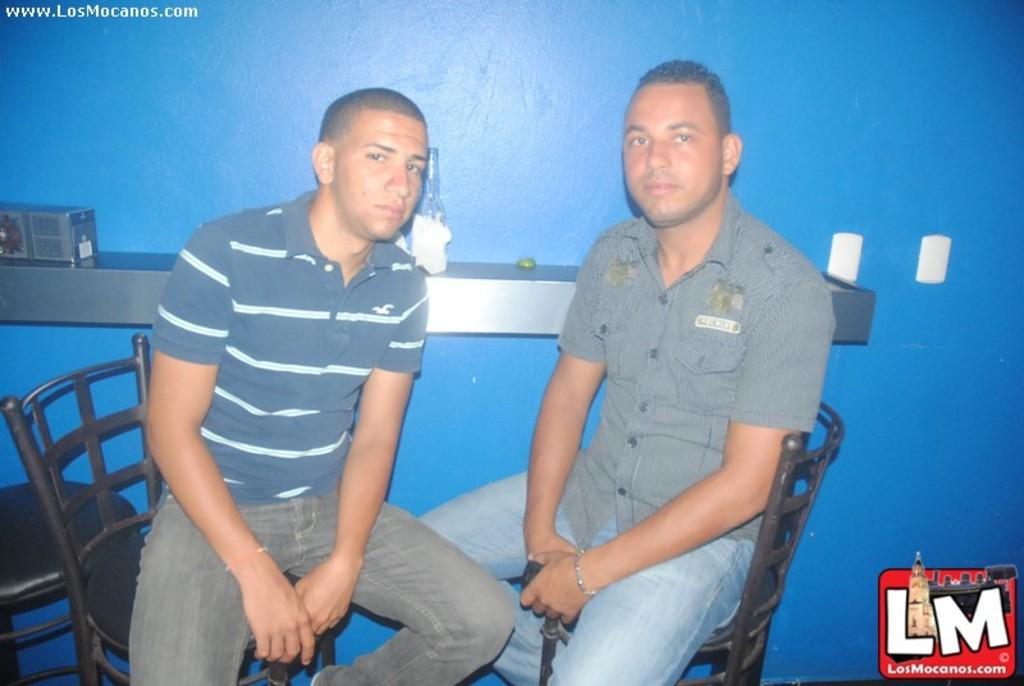How many people are in the image? There are two men in the image. What are the men doing in the image? The men are sitting in a chair. What color is the wall in the background? There is a blue wall in the background. What is attached to the wall in the image? There is a rack fixed on the wall. What can be seen on the rack in the image? There is a bottle on the rack. What type of hat is the man wearing in the image? There is no hat visible in the image; the men are not wearing any headwear. Can you describe the locket that the man is holding in the image? There is no locket present in the image; the men are not holding any jewelry. 